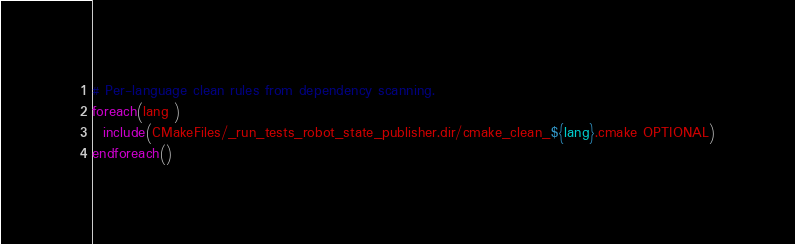<code> <loc_0><loc_0><loc_500><loc_500><_CMake_>
# Per-language clean rules from dependency scanning.
foreach(lang )
  include(CMakeFiles/_run_tests_robot_state_publisher.dir/cmake_clean_${lang}.cmake OPTIONAL)
endforeach()
</code> 